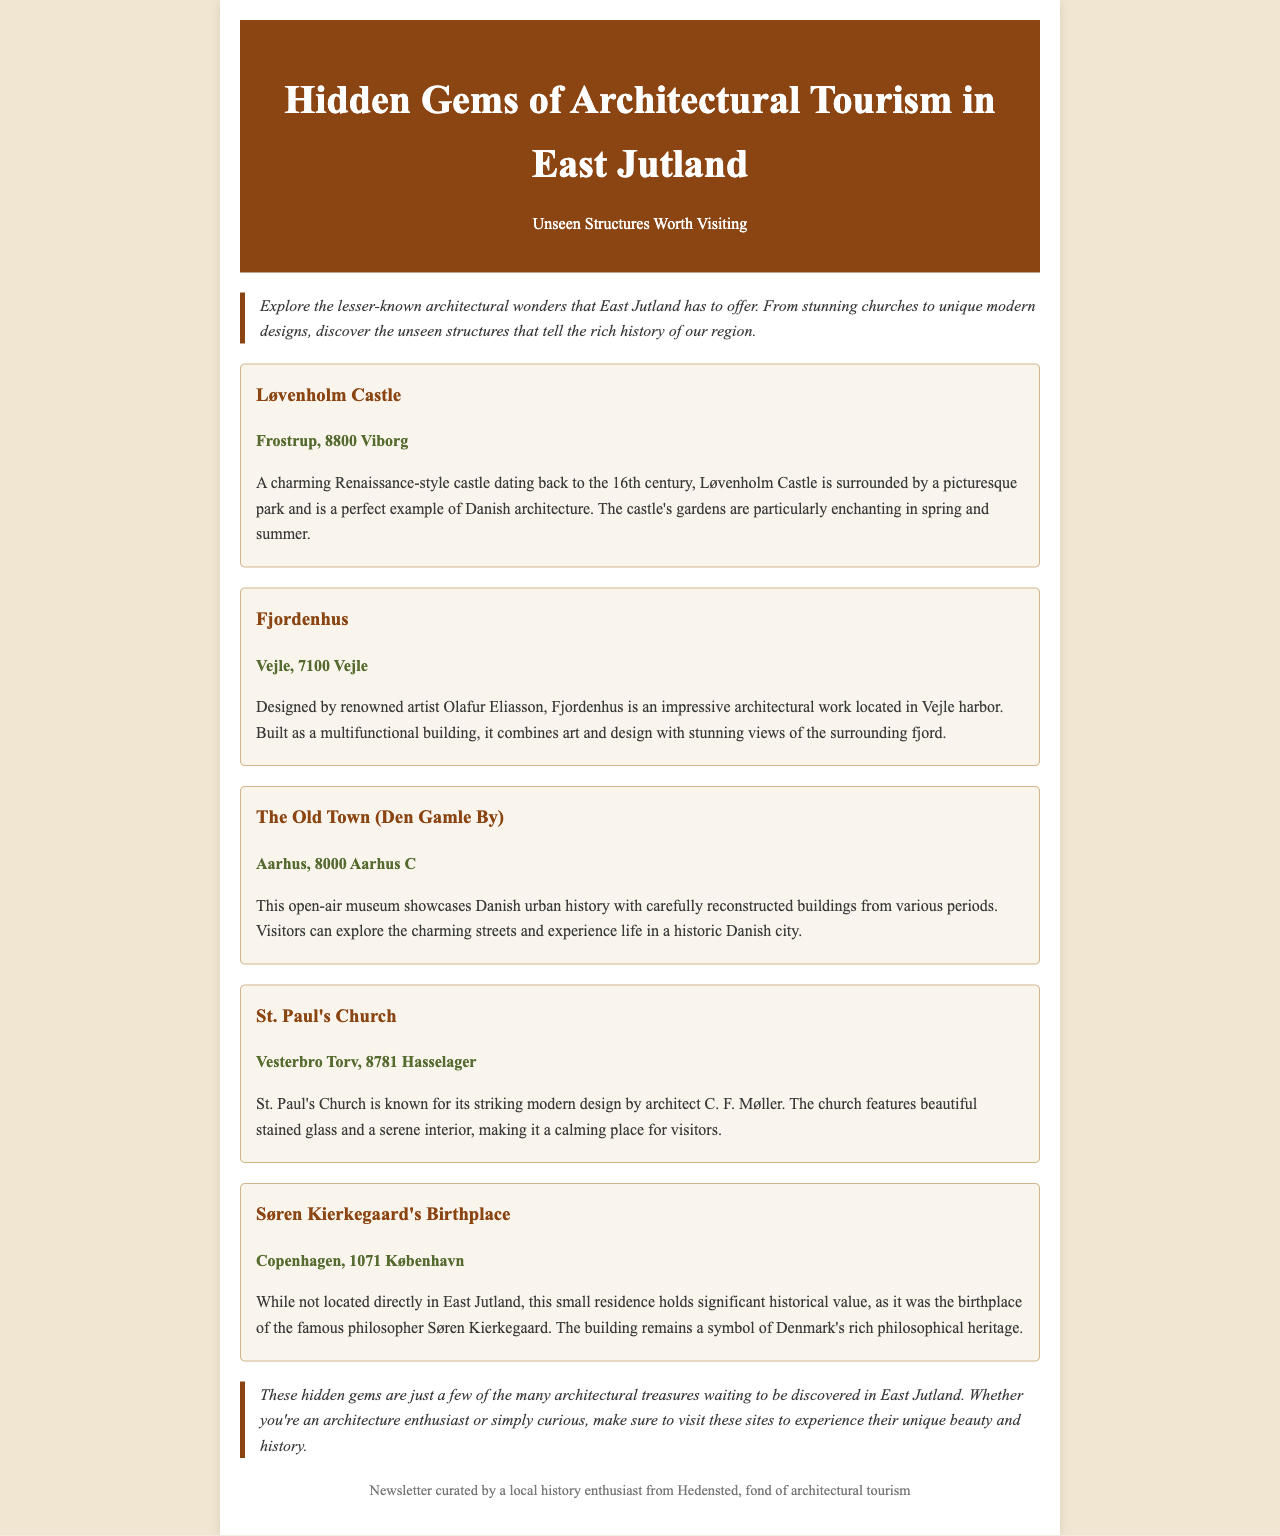What is the title of the newsletter? The title is mentioned at the beginning of the document.
Answer: Hidden Gems of Architectural Tourism in East Jutland Where is Løvenholm Castle located? The location is provided in the description of Løvenholm Castle.
Answer: Frostrup, 8800 Viborg Who designed Fjordenhus? The designer's name is mentioned in the Fjordenhus description.
Answer: Olafur Eliasson What architectural style is St. Paul's Church known for? The architectural style is described in the document regarding St. Paul's Church.
Answer: Modern design How many hidden gems are mentioned in the newsletter? The number of gems can be counted from the descriptions provided in the document.
Answer: Five 